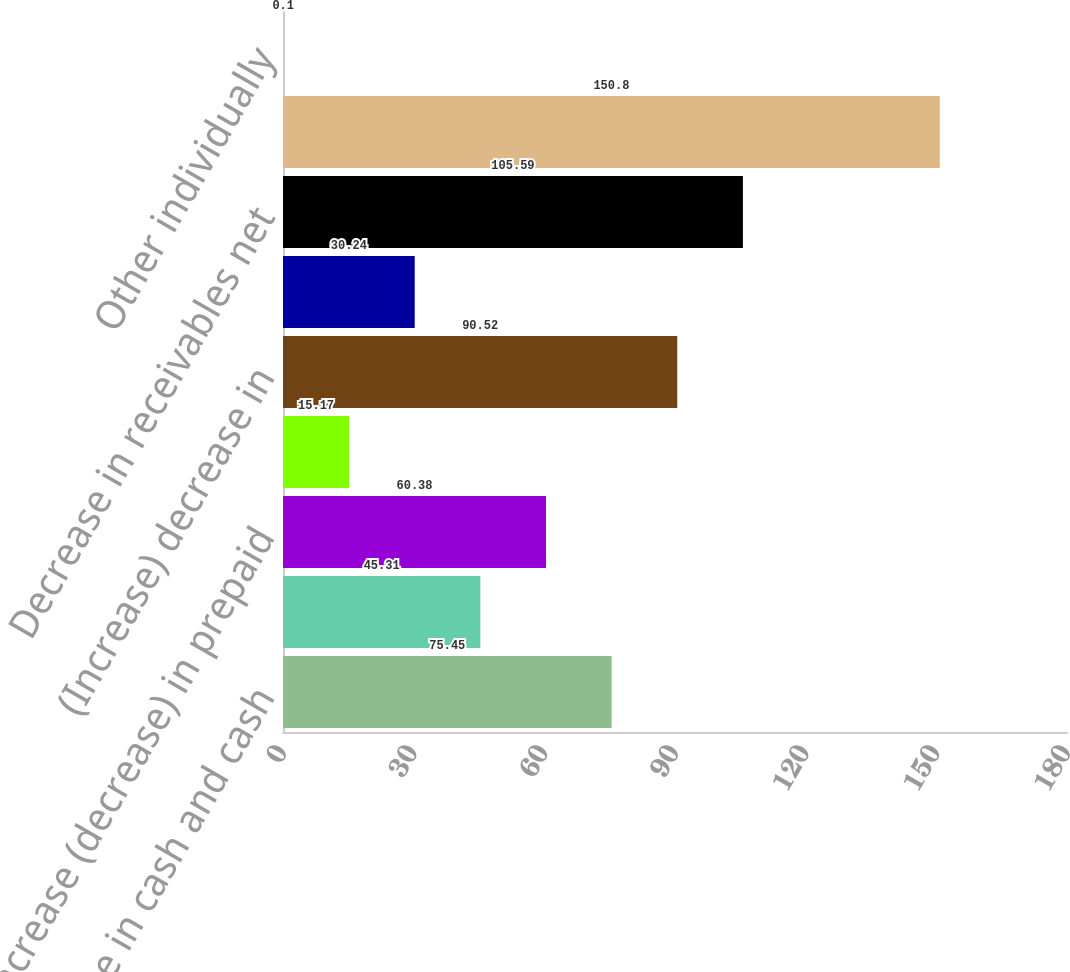<chart> <loc_0><loc_0><loc_500><loc_500><bar_chart><fcel>Increase in cash and cash<fcel>Increase (decrease) in<fcel>Increase (decrease) in prepaid<fcel>Decrease (increase) in current<fcel>(Increase) decrease in<fcel>(Decrease) increase in<fcel>Decrease in receivables net<fcel>Increase in current portion of<fcel>Other individually<nl><fcel>75.45<fcel>45.31<fcel>60.38<fcel>15.17<fcel>90.52<fcel>30.24<fcel>105.59<fcel>150.8<fcel>0.1<nl></chart> 